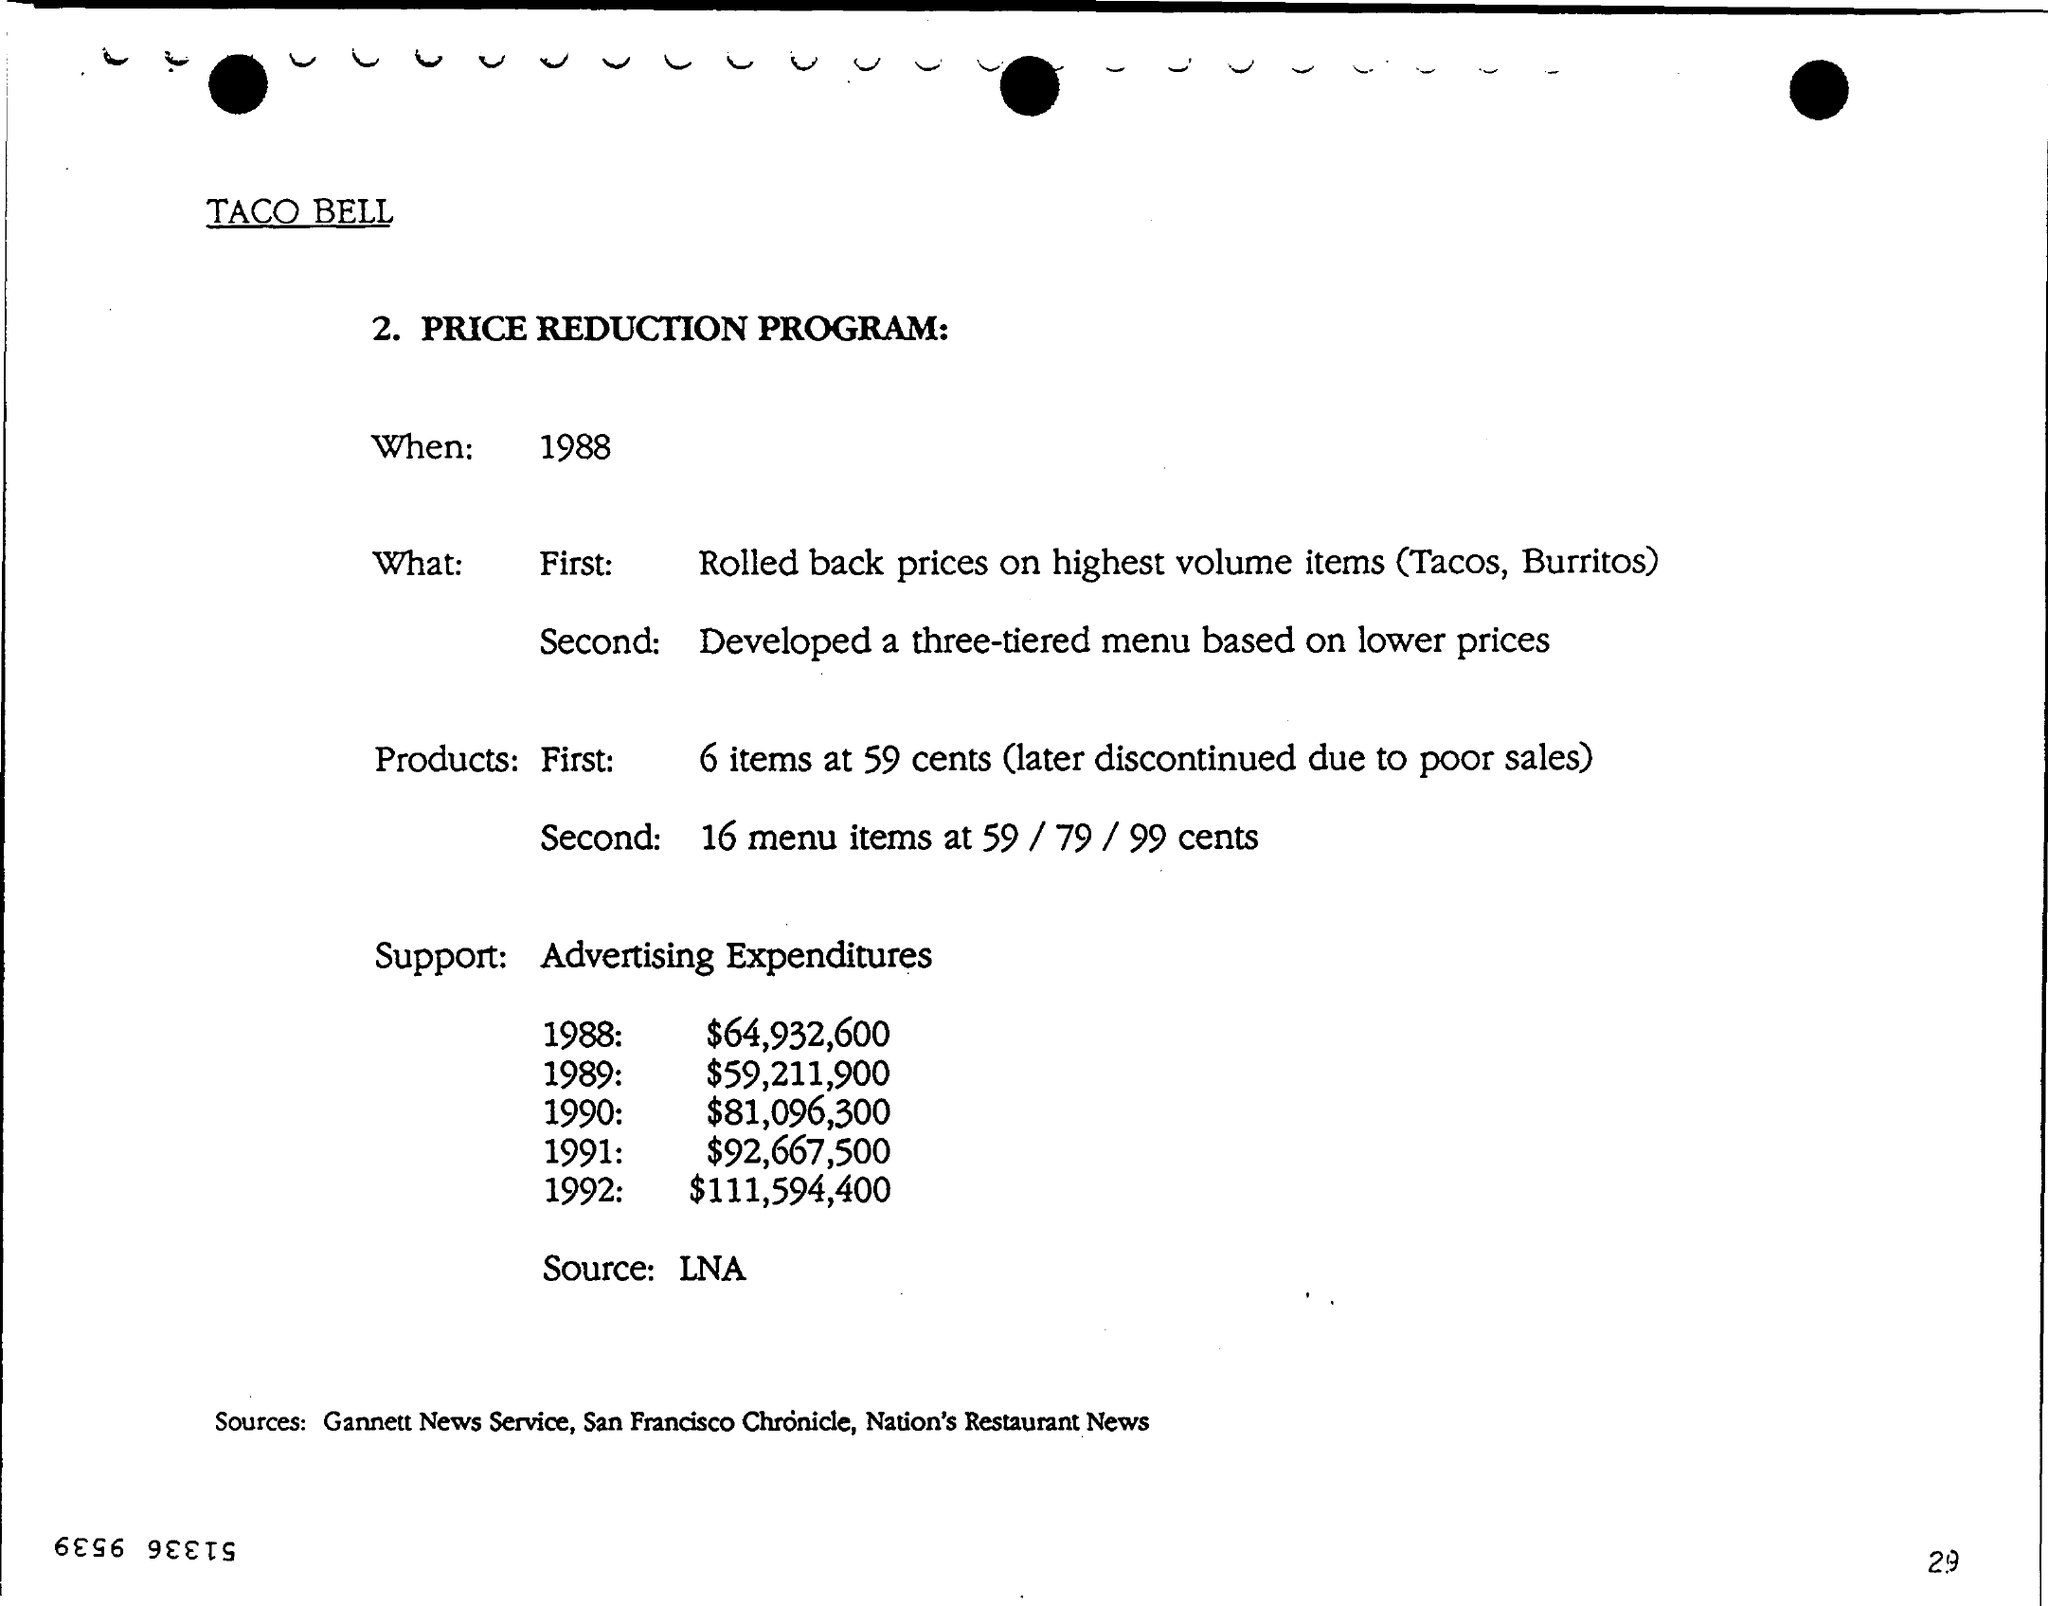Which brand is mentioned?
Offer a terse response. TACO BELL. What is the document about?
Keep it short and to the point. PRICE REDUCTION PROGRAM. When is the PRICE REDUCTION PROGRAM?
Make the answer very short. 1988. What was the advertising expenditure during the year 1991?
Your answer should be compact. $92,667,500. What are the sources mentioned?
Ensure brevity in your answer.  Gannett News service, San Francisco Chronicle, Nation's Restaurant News. 